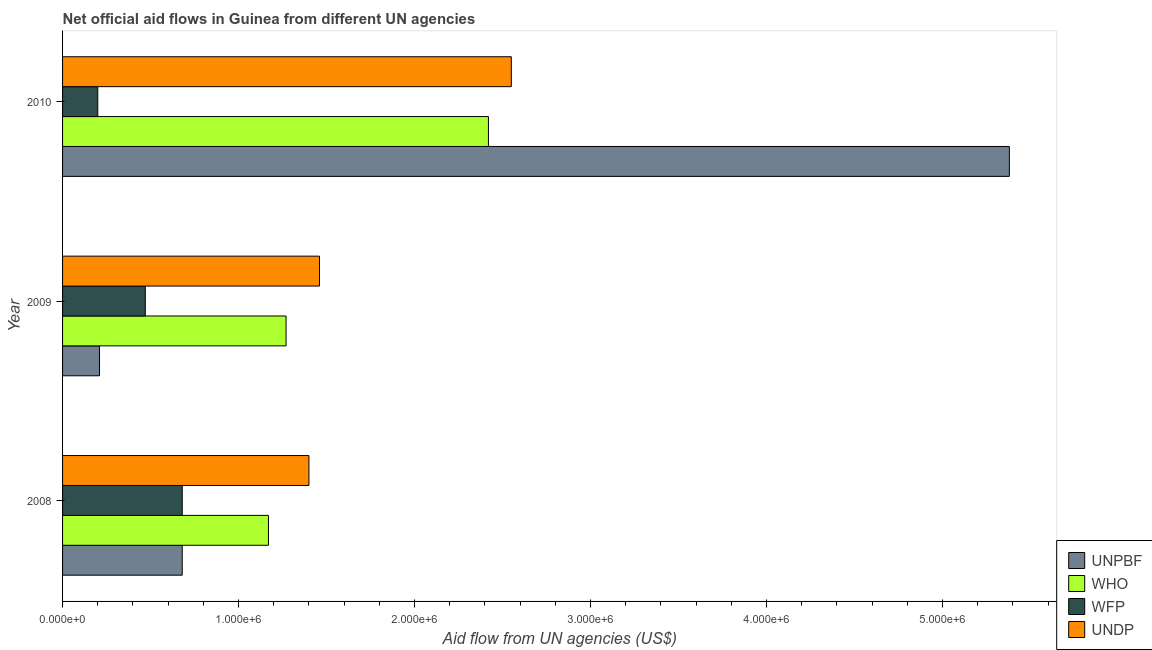Are the number of bars per tick equal to the number of legend labels?
Keep it short and to the point. Yes. How many bars are there on the 2nd tick from the bottom?
Your response must be concise. 4. In how many cases, is the number of bars for a given year not equal to the number of legend labels?
Ensure brevity in your answer.  0. What is the amount of aid given by undp in 2008?
Your response must be concise. 1.40e+06. Across all years, what is the maximum amount of aid given by wfp?
Ensure brevity in your answer.  6.80e+05. Across all years, what is the minimum amount of aid given by who?
Offer a terse response. 1.17e+06. What is the total amount of aid given by wfp in the graph?
Ensure brevity in your answer.  1.35e+06. What is the difference between the amount of aid given by undp in 2009 and that in 2010?
Offer a terse response. -1.09e+06. What is the difference between the amount of aid given by who in 2010 and the amount of aid given by undp in 2009?
Provide a short and direct response. 9.60e+05. What is the average amount of aid given by undp per year?
Your answer should be compact. 1.80e+06. In the year 2009, what is the difference between the amount of aid given by unpbf and amount of aid given by undp?
Offer a very short reply. -1.25e+06. In how many years, is the amount of aid given by who greater than 800000 US$?
Offer a very short reply. 3. What is the ratio of the amount of aid given by who in 2008 to that in 2010?
Keep it short and to the point. 0.48. Is the amount of aid given by unpbf in 2009 less than that in 2010?
Your response must be concise. Yes. Is the difference between the amount of aid given by unpbf in 2008 and 2009 greater than the difference between the amount of aid given by who in 2008 and 2009?
Offer a terse response. Yes. What is the difference between the highest and the second highest amount of aid given by who?
Ensure brevity in your answer.  1.15e+06. What is the difference between the highest and the lowest amount of aid given by undp?
Offer a very short reply. 1.15e+06. In how many years, is the amount of aid given by undp greater than the average amount of aid given by undp taken over all years?
Provide a succinct answer. 1. Is it the case that in every year, the sum of the amount of aid given by unpbf and amount of aid given by wfp is greater than the sum of amount of aid given by undp and amount of aid given by who?
Provide a succinct answer. No. What does the 4th bar from the top in 2008 represents?
Your answer should be compact. UNPBF. What does the 4th bar from the bottom in 2009 represents?
Your answer should be very brief. UNDP. Is it the case that in every year, the sum of the amount of aid given by unpbf and amount of aid given by who is greater than the amount of aid given by wfp?
Provide a succinct answer. Yes. Are all the bars in the graph horizontal?
Keep it short and to the point. Yes. How many years are there in the graph?
Make the answer very short. 3. Are the values on the major ticks of X-axis written in scientific E-notation?
Ensure brevity in your answer.  Yes. Does the graph contain grids?
Give a very brief answer. No. Where does the legend appear in the graph?
Your response must be concise. Bottom right. How are the legend labels stacked?
Provide a succinct answer. Vertical. What is the title of the graph?
Ensure brevity in your answer.  Net official aid flows in Guinea from different UN agencies. Does "Social equity" appear as one of the legend labels in the graph?
Offer a terse response. No. What is the label or title of the X-axis?
Provide a short and direct response. Aid flow from UN agencies (US$). What is the label or title of the Y-axis?
Ensure brevity in your answer.  Year. What is the Aid flow from UN agencies (US$) of UNPBF in 2008?
Offer a terse response. 6.80e+05. What is the Aid flow from UN agencies (US$) in WHO in 2008?
Provide a succinct answer. 1.17e+06. What is the Aid flow from UN agencies (US$) of WFP in 2008?
Offer a very short reply. 6.80e+05. What is the Aid flow from UN agencies (US$) in UNDP in 2008?
Your answer should be very brief. 1.40e+06. What is the Aid flow from UN agencies (US$) of WHO in 2009?
Offer a terse response. 1.27e+06. What is the Aid flow from UN agencies (US$) of WFP in 2009?
Keep it short and to the point. 4.70e+05. What is the Aid flow from UN agencies (US$) in UNDP in 2009?
Provide a short and direct response. 1.46e+06. What is the Aid flow from UN agencies (US$) of UNPBF in 2010?
Provide a succinct answer. 5.38e+06. What is the Aid flow from UN agencies (US$) in WHO in 2010?
Make the answer very short. 2.42e+06. What is the Aid flow from UN agencies (US$) of WFP in 2010?
Keep it short and to the point. 2.00e+05. What is the Aid flow from UN agencies (US$) of UNDP in 2010?
Provide a succinct answer. 2.55e+06. Across all years, what is the maximum Aid flow from UN agencies (US$) of UNPBF?
Give a very brief answer. 5.38e+06. Across all years, what is the maximum Aid flow from UN agencies (US$) of WHO?
Offer a very short reply. 2.42e+06. Across all years, what is the maximum Aid flow from UN agencies (US$) of WFP?
Ensure brevity in your answer.  6.80e+05. Across all years, what is the maximum Aid flow from UN agencies (US$) in UNDP?
Ensure brevity in your answer.  2.55e+06. Across all years, what is the minimum Aid flow from UN agencies (US$) of UNPBF?
Your answer should be very brief. 2.10e+05. Across all years, what is the minimum Aid flow from UN agencies (US$) in WHO?
Give a very brief answer. 1.17e+06. Across all years, what is the minimum Aid flow from UN agencies (US$) in WFP?
Ensure brevity in your answer.  2.00e+05. Across all years, what is the minimum Aid flow from UN agencies (US$) in UNDP?
Provide a succinct answer. 1.40e+06. What is the total Aid flow from UN agencies (US$) in UNPBF in the graph?
Your answer should be compact. 6.27e+06. What is the total Aid flow from UN agencies (US$) of WHO in the graph?
Your response must be concise. 4.86e+06. What is the total Aid flow from UN agencies (US$) in WFP in the graph?
Offer a very short reply. 1.35e+06. What is the total Aid flow from UN agencies (US$) in UNDP in the graph?
Make the answer very short. 5.41e+06. What is the difference between the Aid flow from UN agencies (US$) of UNDP in 2008 and that in 2009?
Provide a short and direct response. -6.00e+04. What is the difference between the Aid flow from UN agencies (US$) of UNPBF in 2008 and that in 2010?
Your answer should be compact. -4.70e+06. What is the difference between the Aid flow from UN agencies (US$) of WHO in 2008 and that in 2010?
Keep it short and to the point. -1.25e+06. What is the difference between the Aid flow from UN agencies (US$) of UNDP in 2008 and that in 2010?
Ensure brevity in your answer.  -1.15e+06. What is the difference between the Aid flow from UN agencies (US$) in UNPBF in 2009 and that in 2010?
Your response must be concise. -5.17e+06. What is the difference between the Aid flow from UN agencies (US$) of WHO in 2009 and that in 2010?
Give a very brief answer. -1.15e+06. What is the difference between the Aid flow from UN agencies (US$) in WFP in 2009 and that in 2010?
Ensure brevity in your answer.  2.70e+05. What is the difference between the Aid flow from UN agencies (US$) in UNDP in 2009 and that in 2010?
Keep it short and to the point. -1.09e+06. What is the difference between the Aid flow from UN agencies (US$) in UNPBF in 2008 and the Aid flow from UN agencies (US$) in WHO in 2009?
Your answer should be compact. -5.90e+05. What is the difference between the Aid flow from UN agencies (US$) in UNPBF in 2008 and the Aid flow from UN agencies (US$) in WFP in 2009?
Give a very brief answer. 2.10e+05. What is the difference between the Aid flow from UN agencies (US$) in UNPBF in 2008 and the Aid flow from UN agencies (US$) in UNDP in 2009?
Your answer should be compact. -7.80e+05. What is the difference between the Aid flow from UN agencies (US$) in WHO in 2008 and the Aid flow from UN agencies (US$) in WFP in 2009?
Offer a terse response. 7.00e+05. What is the difference between the Aid flow from UN agencies (US$) of WHO in 2008 and the Aid flow from UN agencies (US$) of UNDP in 2009?
Make the answer very short. -2.90e+05. What is the difference between the Aid flow from UN agencies (US$) in WFP in 2008 and the Aid flow from UN agencies (US$) in UNDP in 2009?
Provide a succinct answer. -7.80e+05. What is the difference between the Aid flow from UN agencies (US$) of UNPBF in 2008 and the Aid flow from UN agencies (US$) of WHO in 2010?
Your response must be concise. -1.74e+06. What is the difference between the Aid flow from UN agencies (US$) in UNPBF in 2008 and the Aid flow from UN agencies (US$) in WFP in 2010?
Give a very brief answer. 4.80e+05. What is the difference between the Aid flow from UN agencies (US$) in UNPBF in 2008 and the Aid flow from UN agencies (US$) in UNDP in 2010?
Your answer should be very brief. -1.87e+06. What is the difference between the Aid flow from UN agencies (US$) of WHO in 2008 and the Aid flow from UN agencies (US$) of WFP in 2010?
Ensure brevity in your answer.  9.70e+05. What is the difference between the Aid flow from UN agencies (US$) in WHO in 2008 and the Aid flow from UN agencies (US$) in UNDP in 2010?
Your answer should be compact. -1.38e+06. What is the difference between the Aid flow from UN agencies (US$) of WFP in 2008 and the Aid flow from UN agencies (US$) of UNDP in 2010?
Provide a succinct answer. -1.87e+06. What is the difference between the Aid flow from UN agencies (US$) in UNPBF in 2009 and the Aid flow from UN agencies (US$) in WHO in 2010?
Make the answer very short. -2.21e+06. What is the difference between the Aid flow from UN agencies (US$) of UNPBF in 2009 and the Aid flow from UN agencies (US$) of WFP in 2010?
Offer a very short reply. 10000. What is the difference between the Aid flow from UN agencies (US$) in UNPBF in 2009 and the Aid flow from UN agencies (US$) in UNDP in 2010?
Offer a very short reply. -2.34e+06. What is the difference between the Aid flow from UN agencies (US$) in WHO in 2009 and the Aid flow from UN agencies (US$) in WFP in 2010?
Your answer should be very brief. 1.07e+06. What is the difference between the Aid flow from UN agencies (US$) in WHO in 2009 and the Aid flow from UN agencies (US$) in UNDP in 2010?
Offer a very short reply. -1.28e+06. What is the difference between the Aid flow from UN agencies (US$) of WFP in 2009 and the Aid flow from UN agencies (US$) of UNDP in 2010?
Your answer should be compact. -2.08e+06. What is the average Aid flow from UN agencies (US$) of UNPBF per year?
Offer a very short reply. 2.09e+06. What is the average Aid flow from UN agencies (US$) in WHO per year?
Provide a succinct answer. 1.62e+06. What is the average Aid flow from UN agencies (US$) of WFP per year?
Offer a very short reply. 4.50e+05. What is the average Aid flow from UN agencies (US$) of UNDP per year?
Your answer should be very brief. 1.80e+06. In the year 2008, what is the difference between the Aid flow from UN agencies (US$) in UNPBF and Aid flow from UN agencies (US$) in WHO?
Ensure brevity in your answer.  -4.90e+05. In the year 2008, what is the difference between the Aid flow from UN agencies (US$) in UNPBF and Aid flow from UN agencies (US$) in WFP?
Offer a very short reply. 0. In the year 2008, what is the difference between the Aid flow from UN agencies (US$) of UNPBF and Aid flow from UN agencies (US$) of UNDP?
Offer a very short reply. -7.20e+05. In the year 2008, what is the difference between the Aid flow from UN agencies (US$) of WFP and Aid flow from UN agencies (US$) of UNDP?
Offer a very short reply. -7.20e+05. In the year 2009, what is the difference between the Aid flow from UN agencies (US$) in UNPBF and Aid flow from UN agencies (US$) in WHO?
Your response must be concise. -1.06e+06. In the year 2009, what is the difference between the Aid flow from UN agencies (US$) in UNPBF and Aid flow from UN agencies (US$) in WFP?
Keep it short and to the point. -2.60e+05. In the year 2009, what is the difference between the Aid flow from UN agencies (US$) of UNPBF and Aid flow from UN agencies (US$) of UNDP?
Provide a short and direct response. -1.25e+06. In the year 2009, what is the difference between the Aid flow from UN agencies (US$) in WFP and Aid flow from UN agencies (US$) in UNDP?
Make the answer very short. -9.90e+05. In the year 2010, what is the difference between the Aid flow from UN agencies (US$) of UNPBF and Aid flow from UN agencies (US$) of WHO?
Offer a very short reply. 2.96e+06. In the year 2010, what is the difference between the Aid flow from UN agencies (US$) of UNPBF and Aid flow from UN agencies (US$) of WFP?
Give a very brief answer. 5.18e+06. In the year 2010, what is the difference between the Aid flow from UN agencies (US$) in UNPBF and Aid flow from UN agencies (US$) in UNDP?
Make the answer very short. 2.83e+06. In the year 2010, what is the difference between the Aid flow from UN agencies (US$) of WHO and Aid flow from UN agencies (US$) of WFP?
Keep it short and to the point. 2.22e+06. In the year 2010, what is the difference between the Aid flow from UN agencies (US$) in WHO and Aid flow from UN agencies (US$) in UNDP?
Your response must be concise. -1.30e+05. In the year 2010, what is the difference between the Aid flow from UN agencies (US$) of WFP and Aid flow from UN agencies (US$) of UNDP?
Your answer should be very brief. -2.35e+06. What is the ratio of the Aid flow from UN agencies (US$) in UNPBF in 2008 to that in 2009?
Give a very brief answer. 3.24. What is the ratio of the Aid flow from UN agencies (US$) of WHO in 2008 to that in 2009?
Give a very brief answer. 0.92. What is the ratio of the Aid flow from UN agencies (US$) of WFP in 2008 to that in 2009?
Make the answer very short. 1.45. What is the ratio of the Aid flow from UN agencies (US$) of UNDP in 2008 to that in 2009?
Provide a short and direct response. 0.96. What is the ratio of the Aid flow from UN agencies (US$) in UNPBF in 2008 to that in 2010?
Offer a terse response. 0.13. What is the ratio of the Aid flow from UN agencies (US$) of WHO in 2008 to that in 2010?
Give a very brief answer. 0.48. What is the ratio of the Aid flow from UN agencies (US$) in WFP in 2008 to that in 2010?
Provide a succinct answer. 3.4. What is the ratio of the Aid flow from UN agencies (US$) in UNDP in 2008 to that in 2010?
Your answer should be compact. 0.55. What is the ratio of the Aid flow from UN agencies (US$) in UNPBF in 2009 to that in 2010?
Offer a terse response. 0.04. What is the ratio of the Aid flow from UN agencies (US$) in WHO in 2009 to that in 2010?
Keep it short and to the point. 0.52. What is the ratio of the Aid flow from UN agencies (US$) in WFP in 2009 to that in 2010?
Give a very brief answer. 2.35. What is the ratio of the Aid flow from UN agencies (US$) in UNDP in 2009 to that in 2010?
Your answer should be compact. 0.57. What is the difference between the highest and the second highest Aid flow from UN agencies (US$) in UNPBF?
Give a very brief answer. 4.70e+06. What is the difference between the highest and the second highest Aid flow from UN agencies (US$) in WHO?
Make the answer very short. 1.15e+06. What is the difference between the highest and the second highest Aid flow from UN agencies (US$) of WFP?
Ensure brevity in your answer.  2.10e+05. What is the difference between the highest and the second highest Aid flow from UN agencies (US$) in UNDP?
Your answer should be very brief. 1.09e+06. What is the difference between the highest and the lowest Aid flow from UN agencies (US$) in UNPBF?
Your response must be concise. 5.17e+06. What is the difference between the highest and the lowest Aid flow from UN agencies (US$) of WHO?
Offer a terse response. 1.25e+06. What is the difference between the highest and the lowest Aid flow from UN agencies (US$) of UNDP?
Provide a short and direct response. 1.15e+06. 